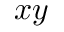Convert formula to latex. <formula><loc_0><loc_0><loc_500><loc_500>x y</formula> 